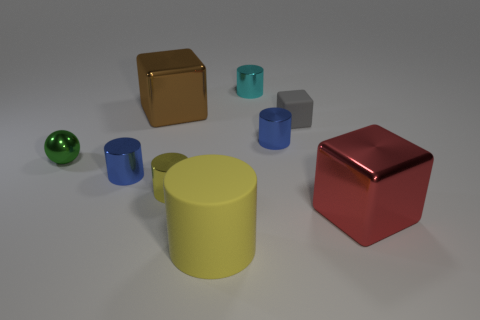Subtract all blue cylinders. How many were subtracted if there are1blue cylinders left? 1 Subtract all blocks. How many objects are left? 6 Subtract 5 cylinders. How many cylinders are left? 0 Subtract all red cylinders. Subtract all red balls. How many cylinders are left? 5 Subtract all brown spheres. How many yellow cylinders are left? 2 Subtract all big metal objects. Subtract all tiny blue cylinders. How many objects are left? 5 Add 1 big red metal objects. How many big red metal objects are left? 2 Add 2 cyan metal things. How many cyan metal things exist? 3 Subtract all cyan cylinders. How many cylinders are left? 4 Subtract all large yellow cylinders. How many cylinders are left? 4 